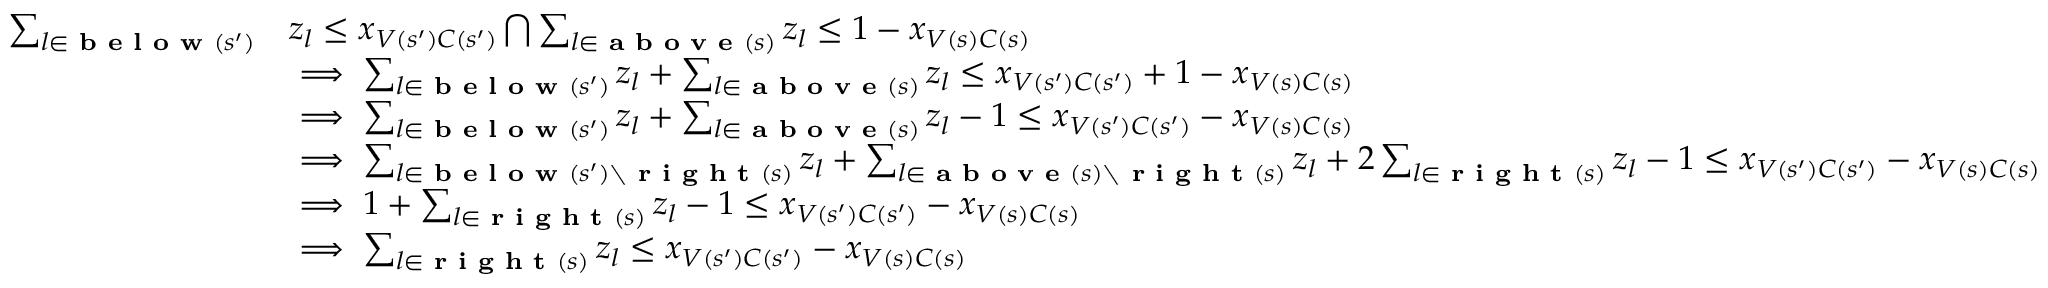Convert formula to latex. <formula><loc_0><loc_0><loc_500><loc_500>\begin{array} { r l } { \sum _ { l \in b e l o w ( s ^ { \prime } ) } } & { z _ { l } \leq x _ { V ( s ^ { \prime } ) C ( s ^ { \prime } ) } \bigcap \sum _ { l \in a b o v e ( s ) } z _ { l } \leq 1 - x _ { V ( s ) C ( s ) } } \\ & { \implies \sum _ { l \in b e l o w ( s ^ { \prime } ) } z _ { l } + \sum _ { l \in a b o v e ( s ) } z _ { l } \leq x _ { V ( s ^ { \prime } ) C ( s ^ { \prime } ) } + 1 - x _ { V ( s ) C ( s ) } } \\ & { \implies \sum _ { l \in b e l o w ( s ^ { \prime } ) } z _ { l } + \sum _ { l \in a b o v e ( s ) } z _ { l } - 1 \leq x _ { V ( s ^ { \prime } ) C ( s ^ { \prime } ) } - x _ { V ( s ) C ( s ) } } \\ & { \implies \sum _ { l \in b e l o w ( s ^ { \prime } ) \ r i g h t ( s ) } z _ { l } + \sum _ { l \in a b o v e ( s ) \ r i g h t ( s ) } z _ { l } + 2 \sum _ { l \in r i g h t ( s ) } z _ { l } - 1 \leq x _ { V ( s ^ { \prime } ) C ( s ^ { \prime } ) } - x _ { V ( s ) C ( s ) } } \\ & { \implies 1 + \sum _ { l \in r i g h t ( s ) } z _ { l } - 1 \leq x _ { V ( s ^ { \prime } ) C ( s ^ { \prime } ) } - x _ { V ( s ) C ( s ) } } \\ & { \implies \sum _ { l \in r i g h t ( s ) } z _ { l } \leq x _ { V ( s ^ { \prime } ) C ( s ^ { \prime } ) } - x _ { V ( s ) C ( s ) } } \end{array}</formula> 